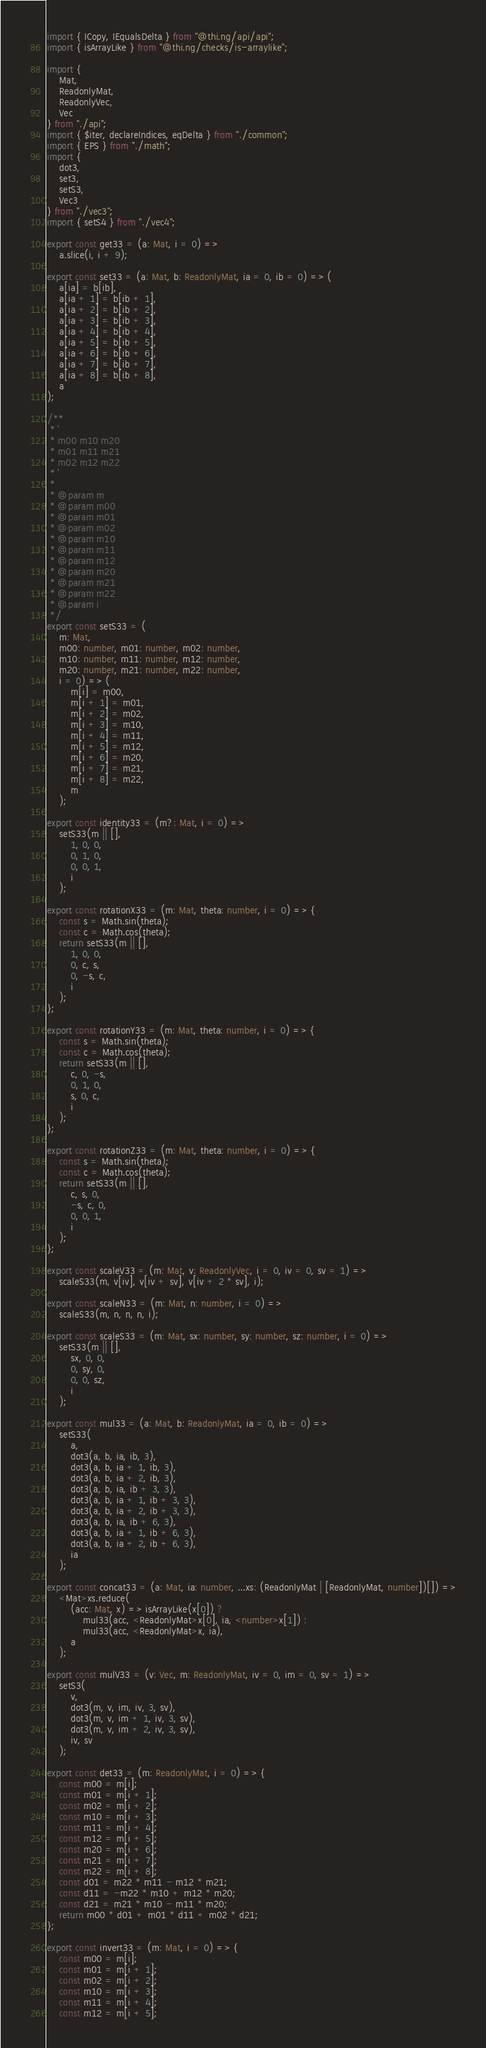Convert code to text. <code><loc_0><loc_0><loc_500><loc_500><_TypeScript_>import { ICopy, IEqualsDelta } from "@thi.ng/api/api";
import { isArrayLike } from "@thi.ng/checks/is-arraylike";

import {
    Mat,
    ReadonlyMat,
    ReadonlyVec,
    Vec
} from "./api";
import { $iter, declareIndices, eqDelta } from "./common";
import { EPS } from "./math";
import {
    dot3,
    set3,
    setS3,
    Vec3
} from "./vec3";
import { setS4 } from "./vec4";

export const get33 = (a: Mat, i = 0) =>
    a.slice(i, i + 9);

export const set33 = (a: Mat, b: ReadonlyMat, ia = 0, ib = 0) => (
    a[ia] = b[ib],
    a[ia + 1] = b[ib + 1],
    a[ia + 2] = b[ib + 2],
    a[ia + 3] = b[ib + 3],
    a[ia + 4] = b[ib + 4],
    a[ia + 5] = b[ib + 5],
    a[ia + 6] = b[ib + 6],
    a[ia + 7] = b[ib + 7],
    a[ia + 8] = b[ib + 8],
    a
);

/**
 * ```
 * m00 m10 m20
 * m01 m11 m21
 * m02 m12 m22
 * ```
 *
 * @param m
 * @param m00
 * @param m01
 * @param m02
 * @param m10
 * @param m11
 * @param m12
 * @param m20
 * @param m21
 * @param m22
 * @param i
 */
export const setS33 = (
    m: Mat,
    m00: number, m01: number, m02: number,
    m10: number, m11: number, m12: number,
    m20: number, m21: number, m22: number,
    i = 0) => (
        m[i] = m00,
        m[i + 1] = m01,
        m[i + 2] = m02,
        m[i + 3] = m10,
        m[i + 4] = m11,
        m[i + 5] = m12,
        m[i + 6] = m20,
        m[i + 7] = m21,
        m[i + 8] = m22,
        m
    );

export const identity33 = (m?: Mat, i = 0) =>
    setS33(m || [],
        1, 0, 0,
        0, 1, 0,
        0, 0, 1,
        i
    );

export const rotationX33 = (m: Mat, theta: number, i = 0) => {
    const s = Math.sin(theta);
    const c = Math.cos(theta);
    return setS33(m || [],
        1, 0, 0,
        0, c, s,
        0, -s, c,
        i
    );
};

export const rotationY33 = (m: Mat, theta: number, i = 0) => {
    const s = Math.sin(theta);
    const c = Math.cos(theta);
    return setS33(m || [],
        c, 0, -s,
        0, 1, 0,
        s, 0, c,
        i
    );
};

export const rotationZ33 = (m: Mat, theta: number, i = 0) => {
    const s = Math.sin(theta);
    const c = Math.cos(theta);
    return setS33(m || [],
        c, s, 0,
        -s, c, 0,
        0, 0, 1,
        i
    );
};

export const scaleV33 = (m: Mat, v: ReadonlyVec, i = 0, iv = 0, sv = 1) =>
    scaleS33(m, v[iv], v[iv + sv], v[iv + 2 * sv], i);

export const scaleN33 = (m: Mat, n: number, i = 0) =>
    scaleS33(m, n, n, n, i);

export const scaleS33 = (m: Mat, sx: number, sy: number, sz: number, i = 0) =>
    setS33(m || [],
        sx, 0, 0,
        0, sy, 0,
        0, 0, sz,
        i
    );

export const mul33 = (a: Mat, b: ReadonlyMat, ia = 0, ib = 0) =>
    setS33(
        a,
        dot3(a, b, ia, ib, 3),
        dot3(a, b, ia + 1, ib, 3),
        dot3(a, b, ia + 2, ib, 3),
        dot3(a, b, ia, ib + 3, 3),
        dot3(a, b, ia + 1, ib + 3, 3),
        dot3(a, b, ia + 2, ib + 3, 3),
        dot3(a, b, ia, ib + 6, 3),
        dot3(a, b, ia + 1, ib + 6, 3),
        dot3(a, b, ia + 2, ib + 6, 3),
        ia
    );

export const concat33 = (a: Mat, ia: number, ...xs: (ReadonlyMat | [ReadonlyMat, number])[]) =>
    <Mat>xs.reduce(
        (acc: Mat, x) => isArrayLike(x[0]) ?
            mul33(acc, <ReadonlyMat>x[0], ia, <number>x[1]) :
            mul33(acc, <ReadonlyMat>x, ia),
        a
    );

export const mulV33 = (v: Vec, m: ReadonlyMat, iv = 0, im = 0, sv = 1) =>
    setS3(
        v,
        dot3(m, v, im, iv, 3, sv),
        dot3(m, v, im + 1, iv, 3, sv),
        dot3(m, v, im + 2, iv, 3, sv),
        iv, sv
    );

export const det33 = (m: ReadonlyMat, i = 0) => {
    const m00 = m[i];
    const m01 = m[i + 1];
    const m02 = m[i + 2];
    const m10 = m[i + 3];
    const m11 = m[i + 4];
    const m12 = m[i + 5];
    const m20 = m[i + 6];
    const m21 = m[i + 7];
    const m22 = m[i + 8];
    const d01 = m22 * m11 - m12 * m21;
    const d11 = -m22 * m10 + m12 * m20;
    const d21 = m21 * m10 - m11 * m20;
    return m00 * d01 + m01 * d11 + m02 * d21;
};

export const invert33 = (m: Mat, i = 0) => {
    const m00 = m[i];
    const m01 = m[i + 1];
    const m02 = m[i + 2];
    const m10 = m[i + 3];
    const m11 = m[i + 4];
    const m12 = m[i + 5];</code> 